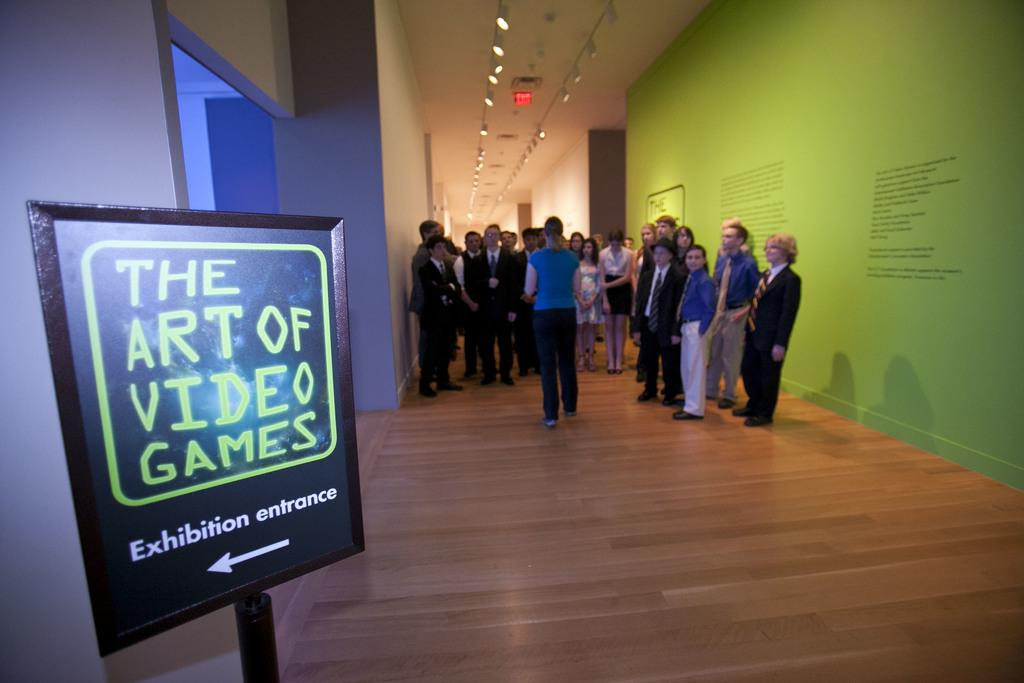<image>
Give a short and clear explanation of the subsequent image. The Art of Video Games Exhibition entrance is to the left. 